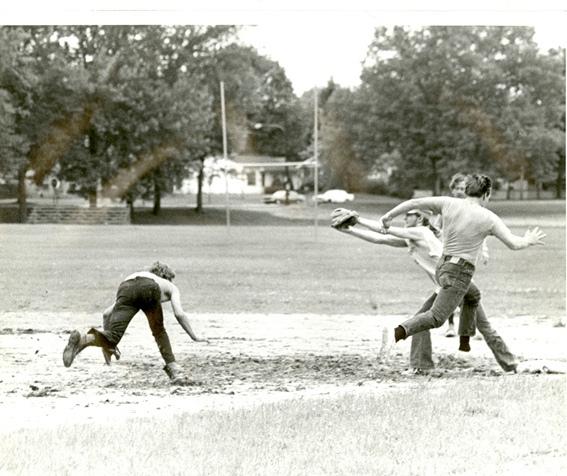What base is the runner running to?
Quick response, please. 1st. Is the photo colored?
Concise answer only. No. Are these professional players?
Short answer required. No. 